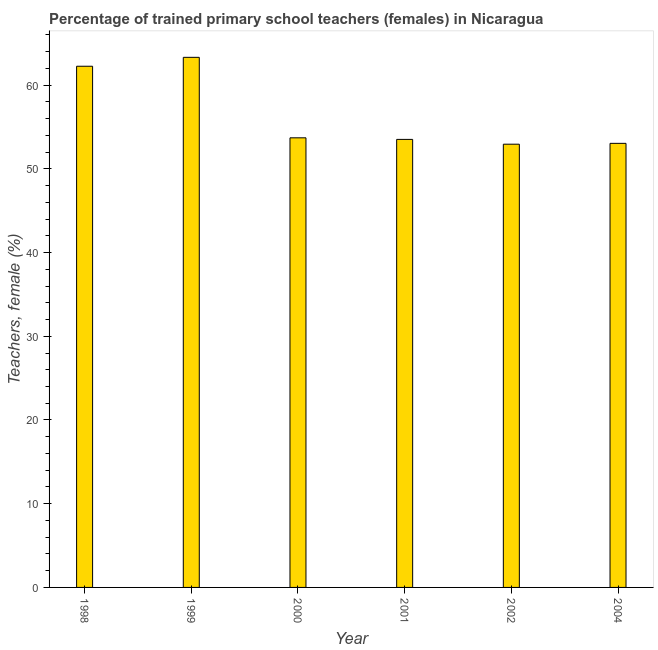Does the graph contain any zero values?
Make the answer very short. No. Does the graph contain grids?
Keep it short and to the point. No. What is the title of the graph?
Your answer should be very brief. Percentage of trained primary school teachers (females) in Nicaragua. What is the label or title of the X-axis?
Your answer should be very brief. Year. What is the label or title of the Y-axis?
Provide a succinct answer. Teachers, female (%). What is the percentage of trained female teachers in 1999?
Offer a terse response. 63.32. Across all years, what is the maximum percentage of trained female teachers?
Make the answer very short. 63.32. Across all years, what is the minimum percentage of trained female teachers?
Make the answer very short. 52.94. In which year was the percentage of trained female teachers maximum?
Offer a very short reply. 1999. What is the sum of the percentage of trained female teachers?
Offer a terse response. 338.8. What is the difference between the percentage of trained female teachers in 1999 and 2002?
Ensure brevity in your answer.  10.38. What is the average percentage of trained female teachers per year?
Make the answer very short. 56.47. What is the median percentage of trained female teachers?
Keep it short and to the point. 53.61. In how many years, is the percentage of trained female teachers greater than 14 %?
Provide a succinct answer. 6. Is the percentage of trained female teachers in 1998 less than that in 1999?
Ensure brevity in your answer.  Yes. Is the difference between the percentage of trained female teachers in 1998 and 2002 greater than the difference between any two years?
Offer a terse response. No. What is the difference between the highest and the second highest percentage of trained female teachers?
Make the answer very short. 1.06. Is the sum of the percentage of trained female teachers in 1998 and 2000 greater than the maximum percentage of trained female teachers across all years?
Your response must be concise. Yes. What is the difference between the highest and the lowest percentage of trained female teachers?
Your response must be concise. 10.38. Are all the bars in the graph horizontal?
Keep it short and to the point. No. How many years are there in the graph?
Your response must be concise. 6. What is the difference between two consecutive major ticks on the Y-axis?
Your answer should be very brief. 10. Are the values on the major ticks of Y-axis written in scientific E-notation?
Provide a short and direct response. No. What is the Teachers, female (%) in 1998?
Offer a terse response. 62.26. What is the Teachers, female (%) of 1999?
Provide a short and direct response. 63.32. What is the Teachers, female (%) in 2000?
Provide a short and direct response. 53.71. What is the Teachers, female (%) of 2001?
Make the answer very short. 53.52. What is the Teachers, female (%) of 2002?
Your answer should be compact. 52.94. What is the Teachers, female (%) of 2004?
Ensure brevity in your answer.  53.05. What is the difference between the Teachers, female (%) in 1998 and 1999?
Your answer should be very brief. -1.06. What is the difference between the Teachers, female (%) in 1998 and 2000?
Make the answer very short. 8.55. What is the difference between the Teachers, female (%) in 1998 and 2001?
Provide a short and direct response. 8.74. What is the difference between the Teachers, female (%) in 1998 and 2002?
Your answer should be very brief. 9.31. What is the difference between the Teachers, female (%) in 1998 and 2004?
Make the answer very short. 9.21. What is the difference between the Teachers, female (%) in 1999 and 2000?
Keep it short and to the point. 9.61. What is the difference between the Teachers, female (%) in 1999 and 2001?
Provide a short and direct response. 9.8. What is the difference between the Teachers, female (%) in 1999 and 2002?
Provide a short and direct response. 10.38. What is the difference between the Teachers, female (%) in 1999 and 2004?
Keep it short and to the point. 10.27. What is the difference between the Teachers, female (%) in 2000 and 2001?
Ensure brevity in your answer.  0.19. What is the difference between the Teachers, female (%) in 2000 and 2002?
Ensure brevity in your answer.  0.76. What is the difference between the Teachers, female (%) in 2000 and 2004?
Provide a short and direct response. 0.66. What is the difference between the Teachers, female (%) in 2001 and 2002?
Give a very brief answer. 0.57. What is the difference between the Teachers, female (%) in 2001 and 2004?
Offer a very short reply. 0.47. What is the difference between the Teachers, female (%) in 2002 and 2004?
Make the answer very short. -0.1. What is the ratio of the Teachers, female (%) in 1998 to that in 1999?
Give a very brief answer. 0.98. What is the ratio of the Teachers, female (%) in 1998 to that in 2000?
Your response must be concise. 1.16. What is the ratio of the Teachers, female (%) in 1998 to that in 2001?
Keep it short and to the point. 1.16. What is the ratio of the Teachers, female (%) in 1998 to that in 2002?
Provide a succinct answer. 1.18. What is the ratio of the Teachers, female (%) in 1998 to that in 2004?
Provide a succinct answer. 1.17. What is the ratio of the Teachers, female (%) in 1999 to that in 2000?
Ensure brevity in your answer.  1.18. What is the ratio of the Teachers, female (%) in 1999 to that in 2001?
Offer a terse response. 1.18. What is the ratio of the Teachers, female (%) in 1999 to that in 2002?
Keep it short and to the point. 1.2. What is the ratio of the Teachers, female (%) in 1999 to that in 2004?
Give a very brief answer. 1.19. What is the ratio of the Teachers, female (%) in 2000 to that in 2002?
Ensure brevity in your answer.  1.01. What is the ratio of the Teachers, female (%) in 2001 to that in 2002?
Offer a terse response. 1.01. What is the ratio of the Teachers, female (%) in 2001 to that in 2004?
Provide a short and direct response. 1.01. 